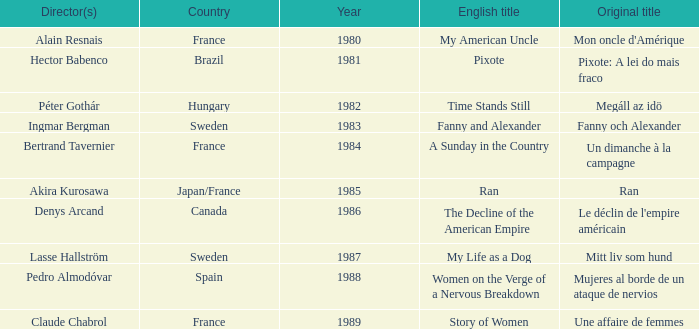What was the original title that was directed by Alain Resnais in France before 1986? Mon oncle d'Amérique. Could you help me parse every detail presented in this table? {'header': ['Director(s)', 'Country', 'Year', 'English title', 'Original title'], 'rows': [['Alain Resnais', 'France', '1980', 'My American Uncle', "Mon oncle d'Amérique"], ['Hector Babenco', 'Brazil', '1981', 'Pixote', 'Pixote: A lei do mais fraco'], ['Péter Gothár', 'Hungary', '1982', 'Time Stands Still', 'Megáll az idö'], ['Ingmar Bergman', 'Sweden', '1983', 'Fanny and Alexander', 'Fanny och Alexander'], ['Bertrand Tavernier', 'France', '1984', 'A Sunday in the Country', 'Un dimanche à la campagne'], ['Akira Kurosawa', 'Japan/France', '1985', 'Ran', 'Ran'], ['Denys Arcand', 'Canada', '1986', 'The Decline of the American Empire', "Le déclin de l'empire américain"], ['Lasse Hallström', 'Sweden', '1987', 'My Life as a Dog', 'Mitt liv som hund'], ['Pedro Almodóvar', 'Spain', '1988', 'Women on the Verge of a Nervous Breakdown', 'Mujeres al borde de un ataque de nervios'], ['Claude Chabrol', 'France', '1989', 'Story of Women', 'Une affaire de femmes']]} 